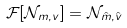<formula> <loc_0><loc_0><loc_500><loc_500>\mathcal { F } [ \mathcal { N } _ { m , v } ] = \mathcal { N } _ { \hat { m } , \hat { v } }</formula> 